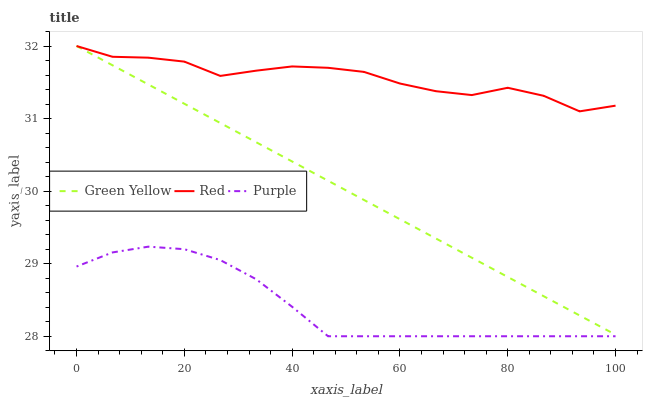Does Purple have the minimum area under the curve?
Answer yes or no. Yes. Does Red have the maximum area under the curve?
Answer yes or no. Yes. Does Green Yellow have the minimum area under the curve?
Answer yes or no. No. Does Green Yellow have the maximum area under the curve?
Answer yes or no. No. Is Green Yellow the smoothest?
Answer yes or no. Yes. Is Red the roughest?
Answer yes or no. Yes. Is Red the smoothest?
Answer yes or no. No. Is Green Yellow the roughest?
Answer yes or no. No. Does Purple have the lowest value?
Answer yes or no. Yes. Does Green Yellow have the lowest value?
Answer yes or no. No. Does Red have the highest value?
Answer yes or no. Yes. Is Purple less than Green Yellow?
Answer yes or no. Yes. Is Green Yellow greater than Purple?
Answer yes or no. Yes. Does Green Yellow intersect Red?
Answer yes or no. Yes. Is Green Yellow less than Red?
Answer yes or no. No. Is Green Yellow greater than Red?
Answer yes or no. No. Does Purple intersect Green Yellow?
Answer yes or no. No. 